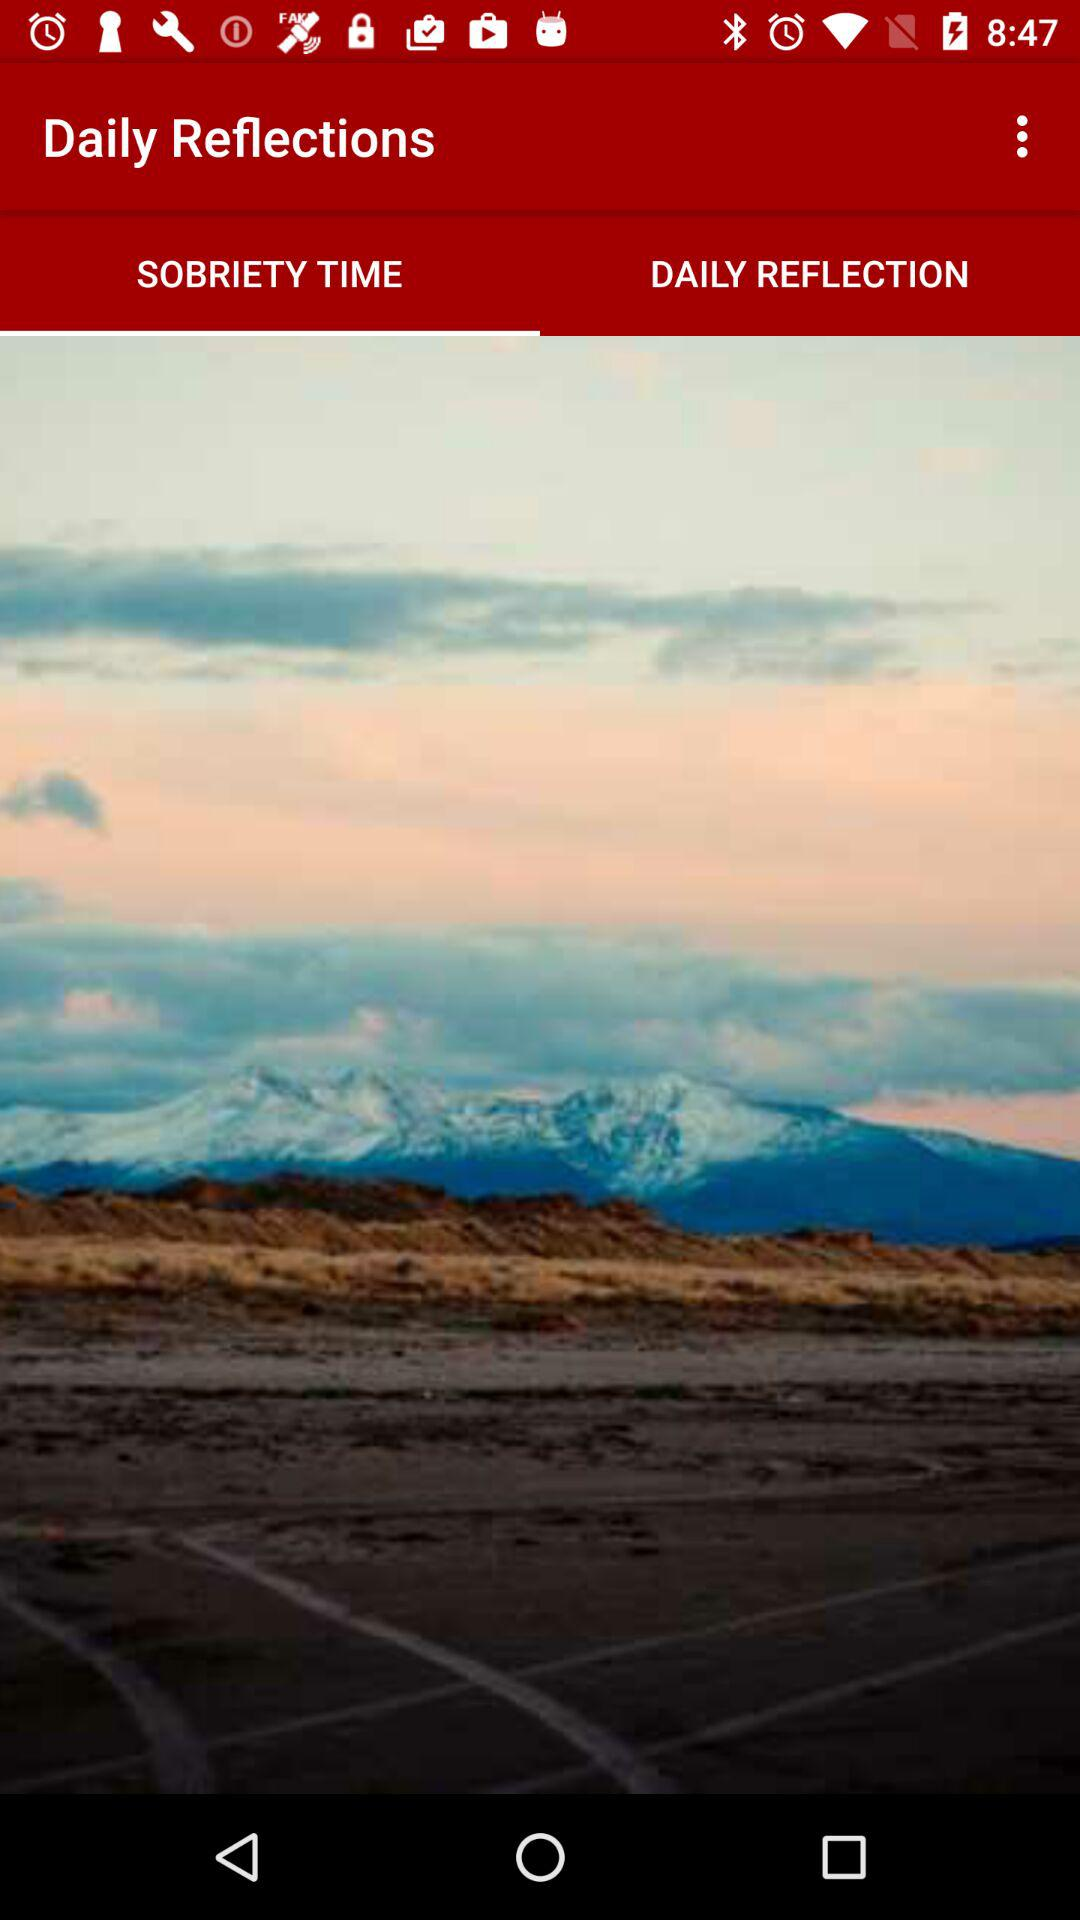What is the name of the application? The name of the application is "Daily Reflections". 